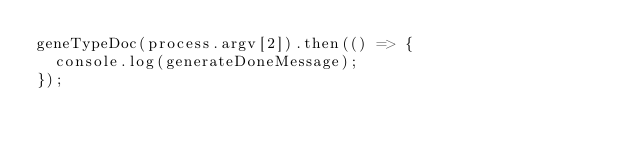<code> <loc_0><loc_0><loc_500><loc_500><_TypeScript_>geneTypeDoc(process.argv[2]).then(() => {
  console.log(generateDoneMessage);
});
</code> 